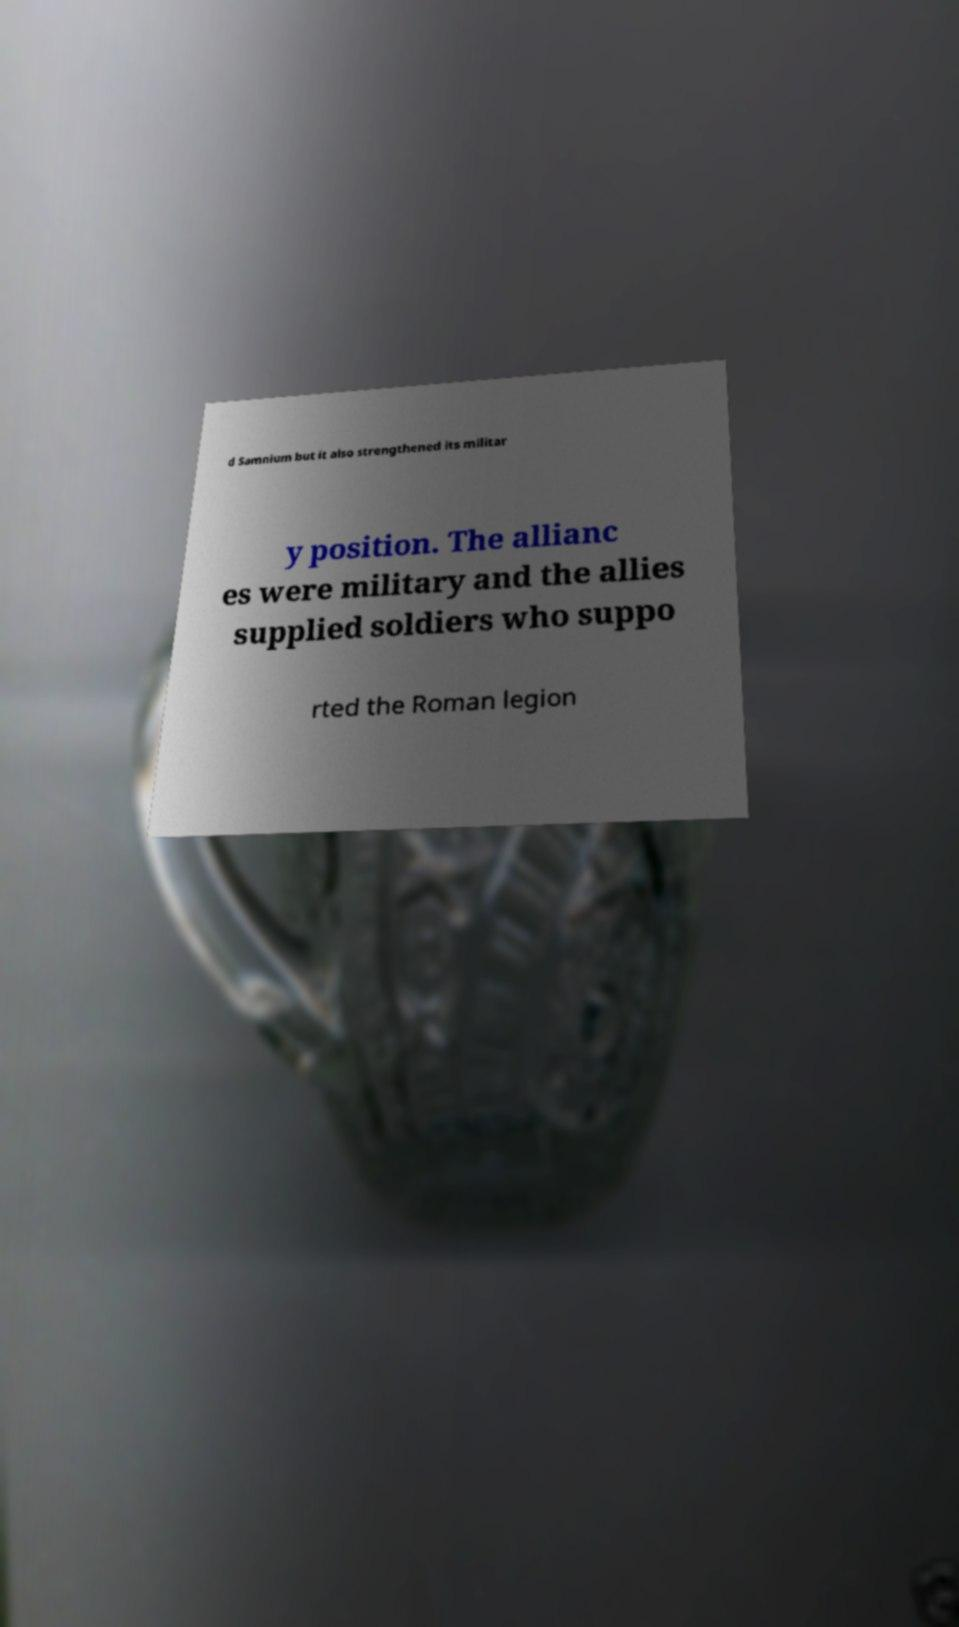Could you extract and type out the text from this image? d Samnium but it also strengthened its militar y position. The allianc es were military and the allies supplied soldiers who suppo rted the Roman legion 